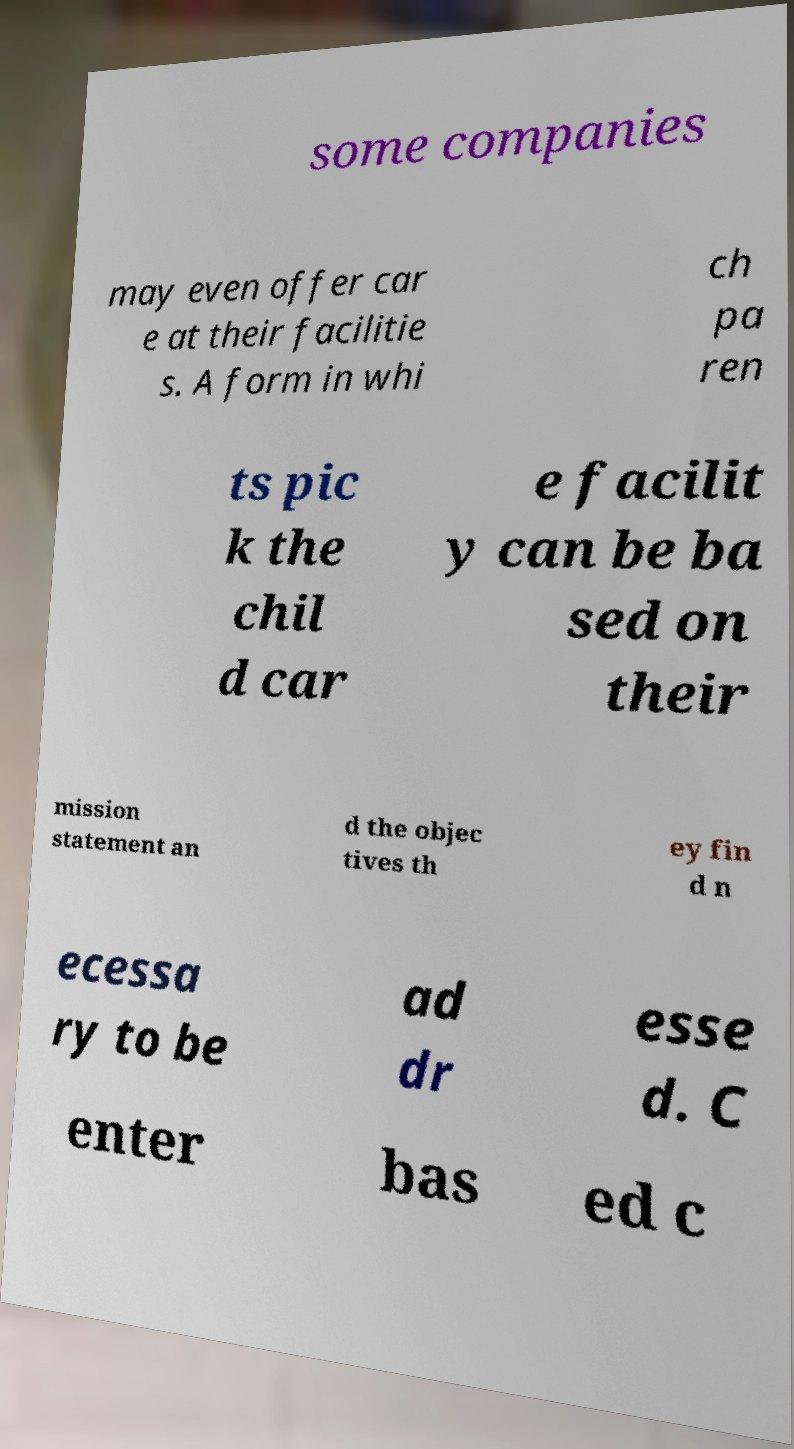Please identify and transcribe the text found in this image. some companies may even offer car e at their facilitie s. A form in whi ch pa ren ts pic k the chil d car e facilit y can be ba sed on their mission statement an d the objec tives th ey fin d n ecessa ry to be ad dr esse d. C enter bas ed c 